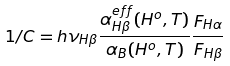Convert formula to latex. <formula><loc_0><loc_0><loc_500><loc_500>1 / C = h \nu _ { H { \beta } } \frac { \alpha ^ { e f f } _ { H \beta } ( H ^ { o } , T ) } { \alpha _ { B } ( H ^ { o } , T ) } \frac { F _ { H \alpha } } { F _ { H \beta } }</formula> 